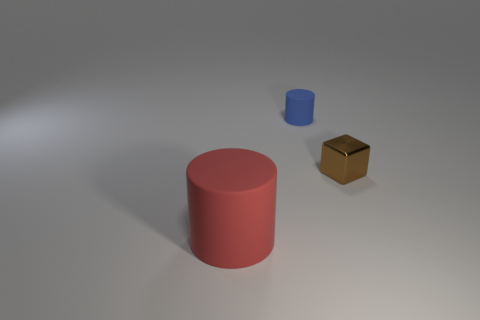Are there any other things that have the same size as the red rubber cylinder?
Provide a succinct answer. No. The blue object that is the same material as the big red thing is what size?
Offer a very short reply. Small. Are there an equal number of tiny matte things that are in front of the brown metal object and things on the right side of the big red rubber cylinder?
Provide a short and direct response. No. Is there anything else that has the same material as the brown cube?
Make the answer very short. No. What color is the small thing that is behind the brown thing?
Give a very brief answer. Blue. Is the number of brown blocks right of the blue rubber cylinder the same as the number of small purple metal objects?
Provide a short and direct response. No. What number of other objects are there of the same shape as the tiny blue thing?
Keep it short and to the point. 1. How many rubber things are to the left of the blue matte thing?
Make the answer very short. 1. There is a thing that is to the right of the big red matte cylinder and left of the tiny metal block; what size is it?
Make the answer very short. Small. Is there a tiny purple matte cube?
Your answer should be compact. No. 